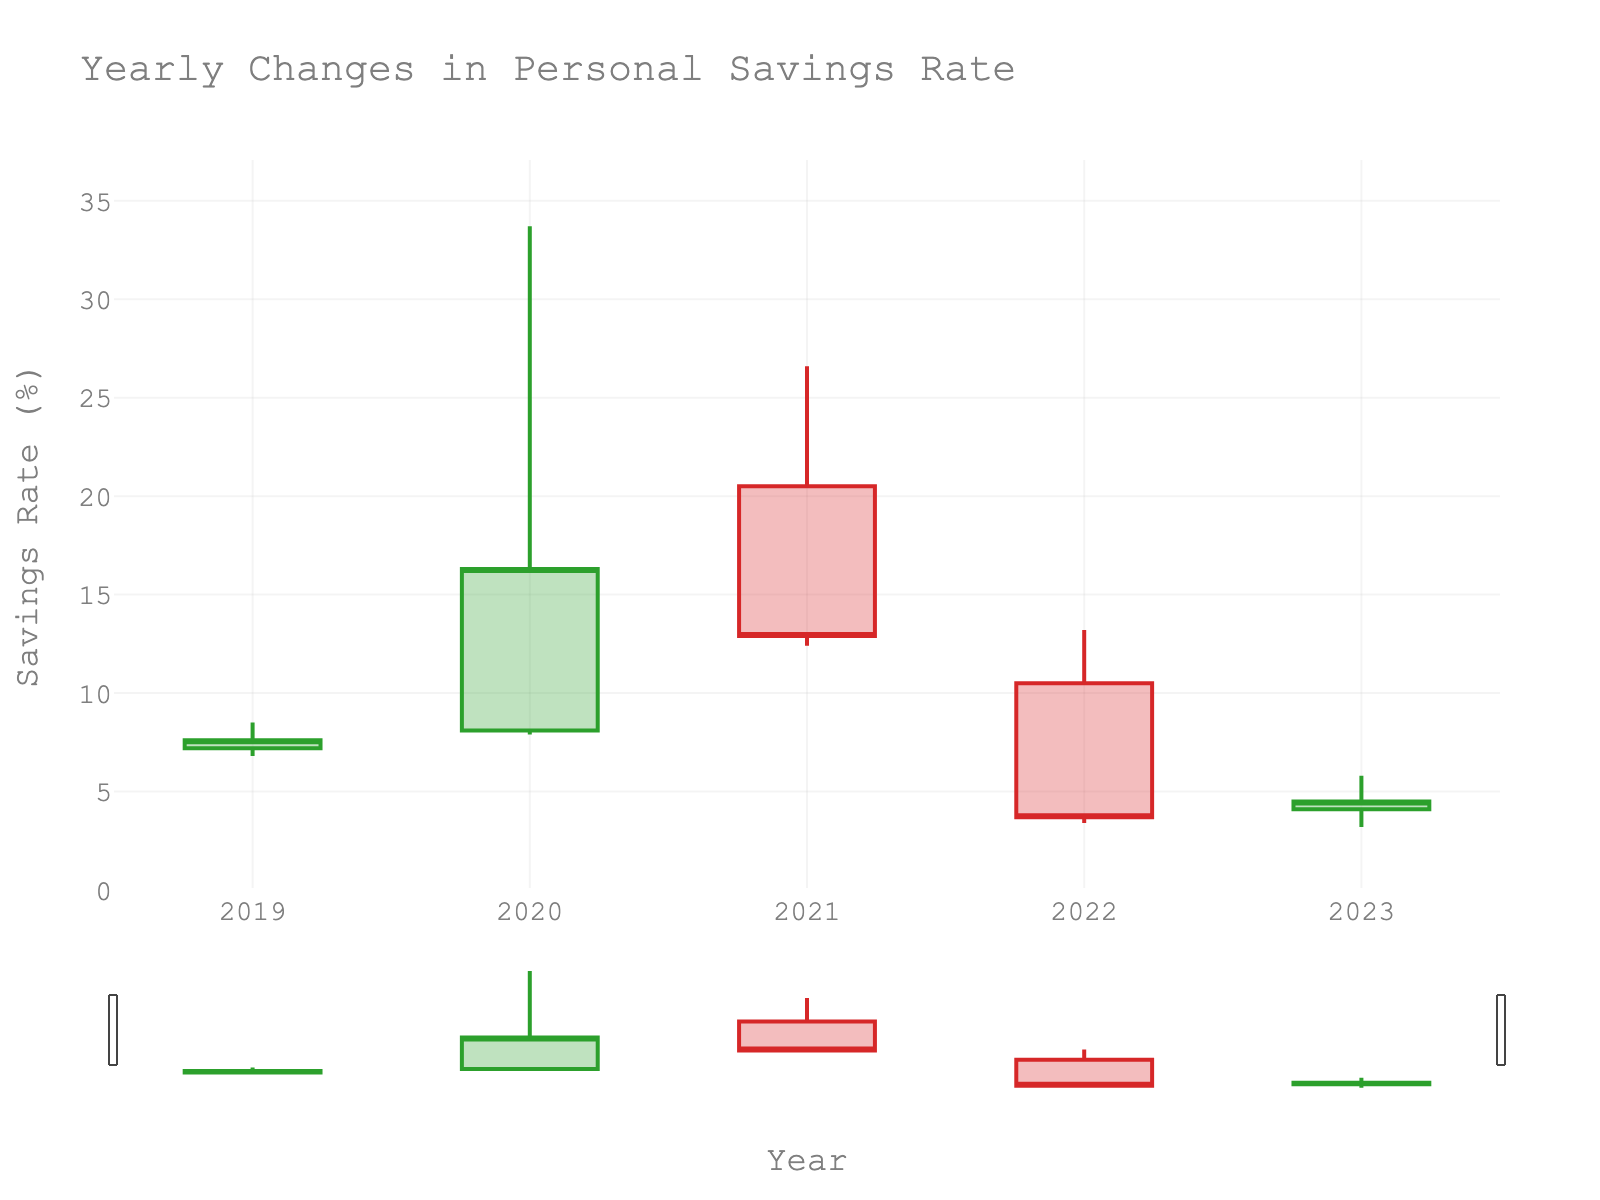what is the highest savings rate recorded in the figure? The highest savings rate is the maximum value reached by any 'High' point in the OHLC chart. By looking at the peaks in the figure, the highest savings rate recorded is 33.7% in 2020.
Answer: 33.7% In which year did the savings rate close at its highest value? To answer this, we compare the 'Close' values for each year. The highest 'Close' value is 16.3% in 2020.
Answer: 2020 Which year had the largest range in savings rate? The range is calculated as 'High' minus 'Low' for each year. Comparing the ranges: 1.7 (2019), 25.8 (2020), 14.2 (2021), 9.8 (2022), 2.6 (2023). The year with the largest range is 2020 with a range of 25.8%.
Answer: 2020 Which years have a decreasing trend in the savings rate? A year has a decreasing trend if the 'Close' value is lower than the 'Open' value. This happens in 2021 and 2022.
Answer: 2021 and 2022 What's the average closing savings rate over the five years? Sum the 'Close' values and divide by the number of years: (7.6 + 16.3 + 12.9 + 3.7 + 4.5) / 5 = 9.0%.
Answer: 9.0% Which year had the lowest opening savings rate? Compare the 'Open' values for all years. The lowest 'Open' value is 4.1% in 2023.
Answer: 2023 How did the savings rate in 2023 compare to 2019 in terms of the closing value? The closing value in 2019 was 7.6% and in 2023 it was 4.5%. Comparing these, the savings rate closed lower in 2023 than in 2019.
Answer: Lower in 2023 What can we infer about the financial discipline progress from 2020 to 2023? By observing the decreasing 'Close' values over these years (16.3% in 2020, 12.9% in 2021, 3.7% in 2022, and 4.5% in 2023), we infer a declining trend in savings rate, suggesting a challenge in maintaining financial discipline.
Answer: Decline in financial discipline Which year saw the smallest difference between its opening and closing savings rates? The difference is calculated by subtracting 'Open' from 'Close' for each year. Comparing the differences: 0.4 (2019), 8.2 (2020), 7.6 (2021), -6.8 (2022), 0.4 (2023). The smallest differences are 0.4 in 2019 and 2023.
Answer: 2019 and 2023 